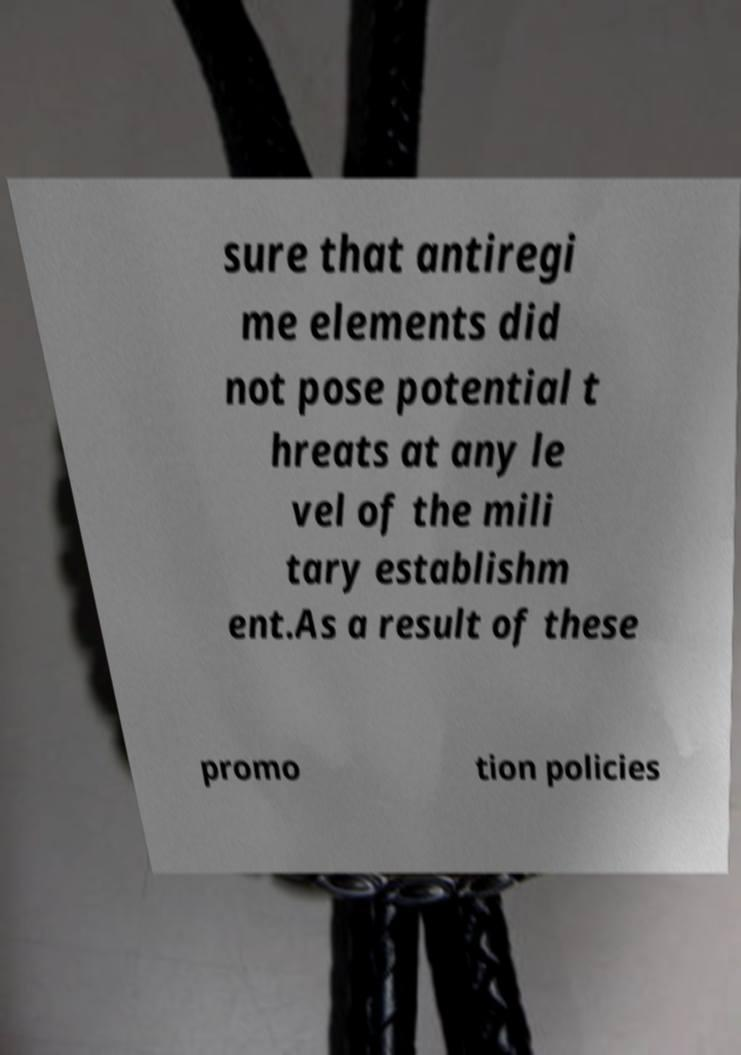What messages or text are displayed in this image? I need them in a readable, typed format. sure that antiregi me elements did not pose potential t hreats at any le vel of the mili tary establishm ent.As a result of these promo tion policies 